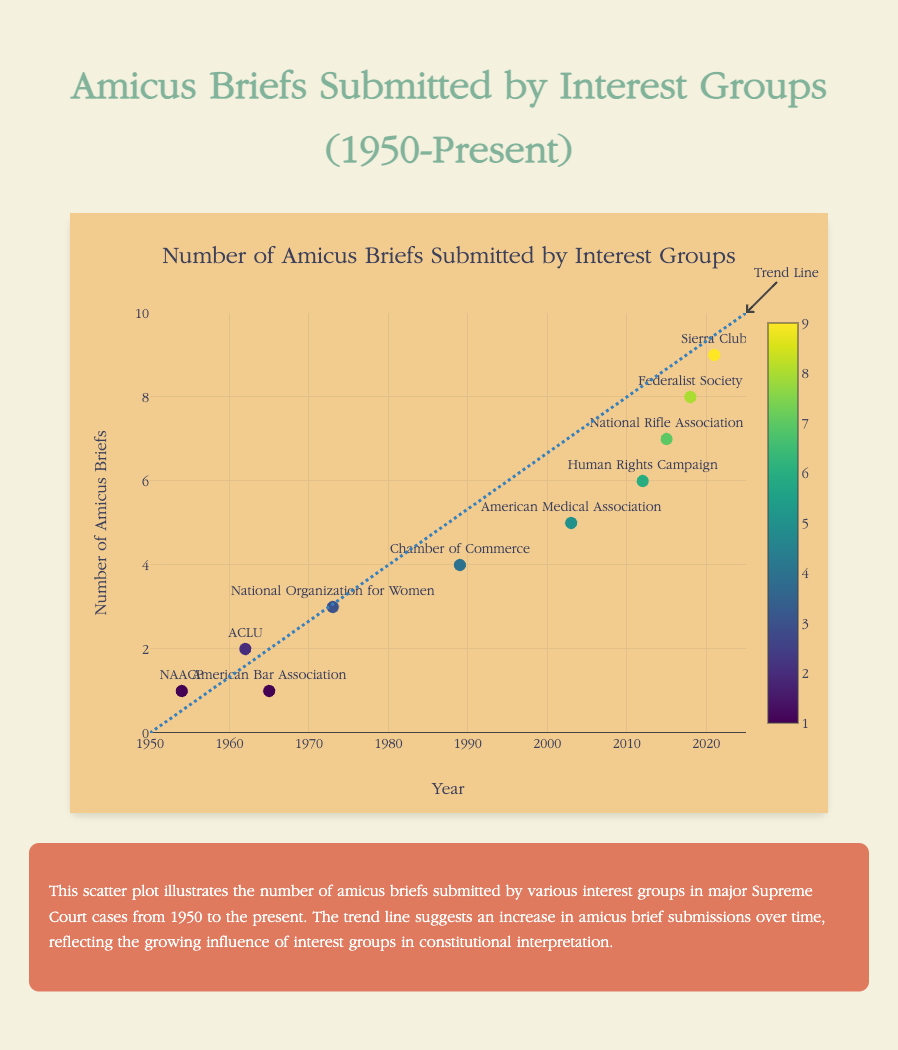What is the title of the chart? The title is usually located at the top of the chart. Here, it reads "Number of Amicus Briefs Submitted by Interest Groups" in a large, centered font.
Answer: Number of Amicus Briefs Submitted by Interest Groups Which interest group submitted the most amicus briefs in major Supreme Court cases? By looking at the scatter plot, the data point with the highest y-value indicates the group with the most amicus briefs. This data point belongs to the Sierra Club in 2021, with 9 briefs.
Answer: Sierra Club What is the range of years displayed on the x-axis? The x-axis shows the years from 1950 to 2025. This is highlighted by the axis labels and the overall spread of data points along the x-axis.
Answer: 1950 to 2025 How many amicus briefs were submitted by the National Organization for Women and in what year? By examining the data points and their associated text labels, the National Organization for Women submitted 3 amicus briefs in 1973.
Answer: 3 briefs in 1973 How many total amicus briefs were submitted by the ACLU over the years shown? By checking the data associated with the ACLU's data point, the ACLU submitted 2 amicus briefs in 1962. Being only one data point, no summing is necessary.
Answer: 2 Comparing 1954 and 2012, by how much has the number of amicus briefs changed? In 1954 (NAACP), there was 1 brief submitted, while in 2012 (Human Rights Campaign), there were 6 briefs. The difference between them is 6 - 1 = 5.
Answer: Increased by 5 Which color scheme is used for the markers, and what does it represent? The color of the markers follows the Viridis color scale, representing the number of amicus briefs each group has submitted, from the lightest to the darkest color showing the increasing number of briefs. The color bar on the right indicates this.
Answer: Viridis color scale representing number of briefs What trend is indicated by the trend line in the chart? The trend line, which extends from 0 briefs in 1950 to 10 briefs in 2025, indicates an upward trend where the number of amicus briefs submitted by interest groups has been increasing over time.
Answer: An increase in amicus briefs over time How many interest groups submitted more than 5 amicus briefs? Examining the scatter plot, groups above the y = 5 line are *Human Rights Campaign (6), National Rifle Association (7), Federalist Society (8), and Sierra Club (9)*, making a total of 4 groups.
Answer: 4 Which group, according to the plot, had the same number of amicus briefs as the American Bar Association, and in what year? Both the American Bar Association in 1965, and NAACP in 1954, submitted 1 amicus brief each.
Answer: NAACP in 1954 